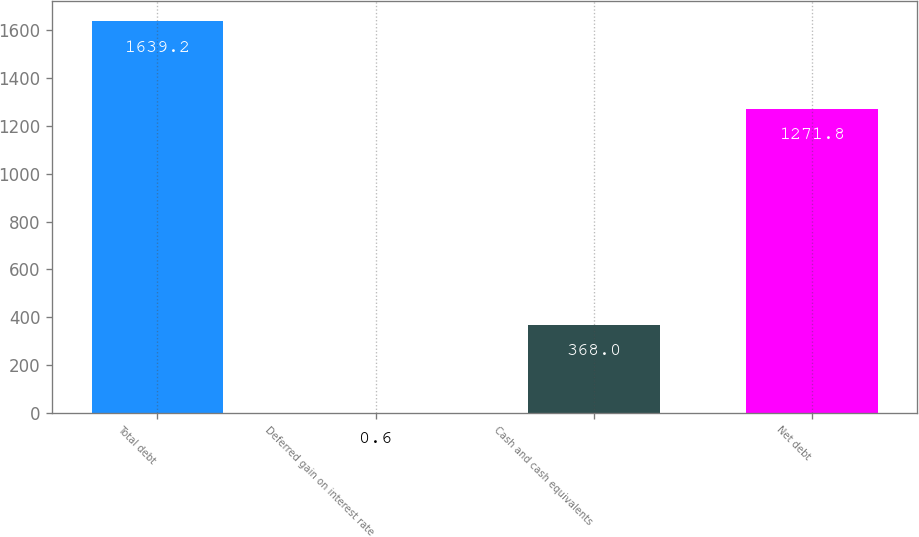Convert chart to OTSL. <chart><loc_0><loc_0><loc_500><loc_500><bar_chart><fcel>Total debt<fcel>Deferred gain on interest rate<fcel>Cash and cash equivalents<fcel>Net debt<nl><fcel>1639.2<fcel>0.6<fcel>368<fcel>1271.8<nl></chart> 